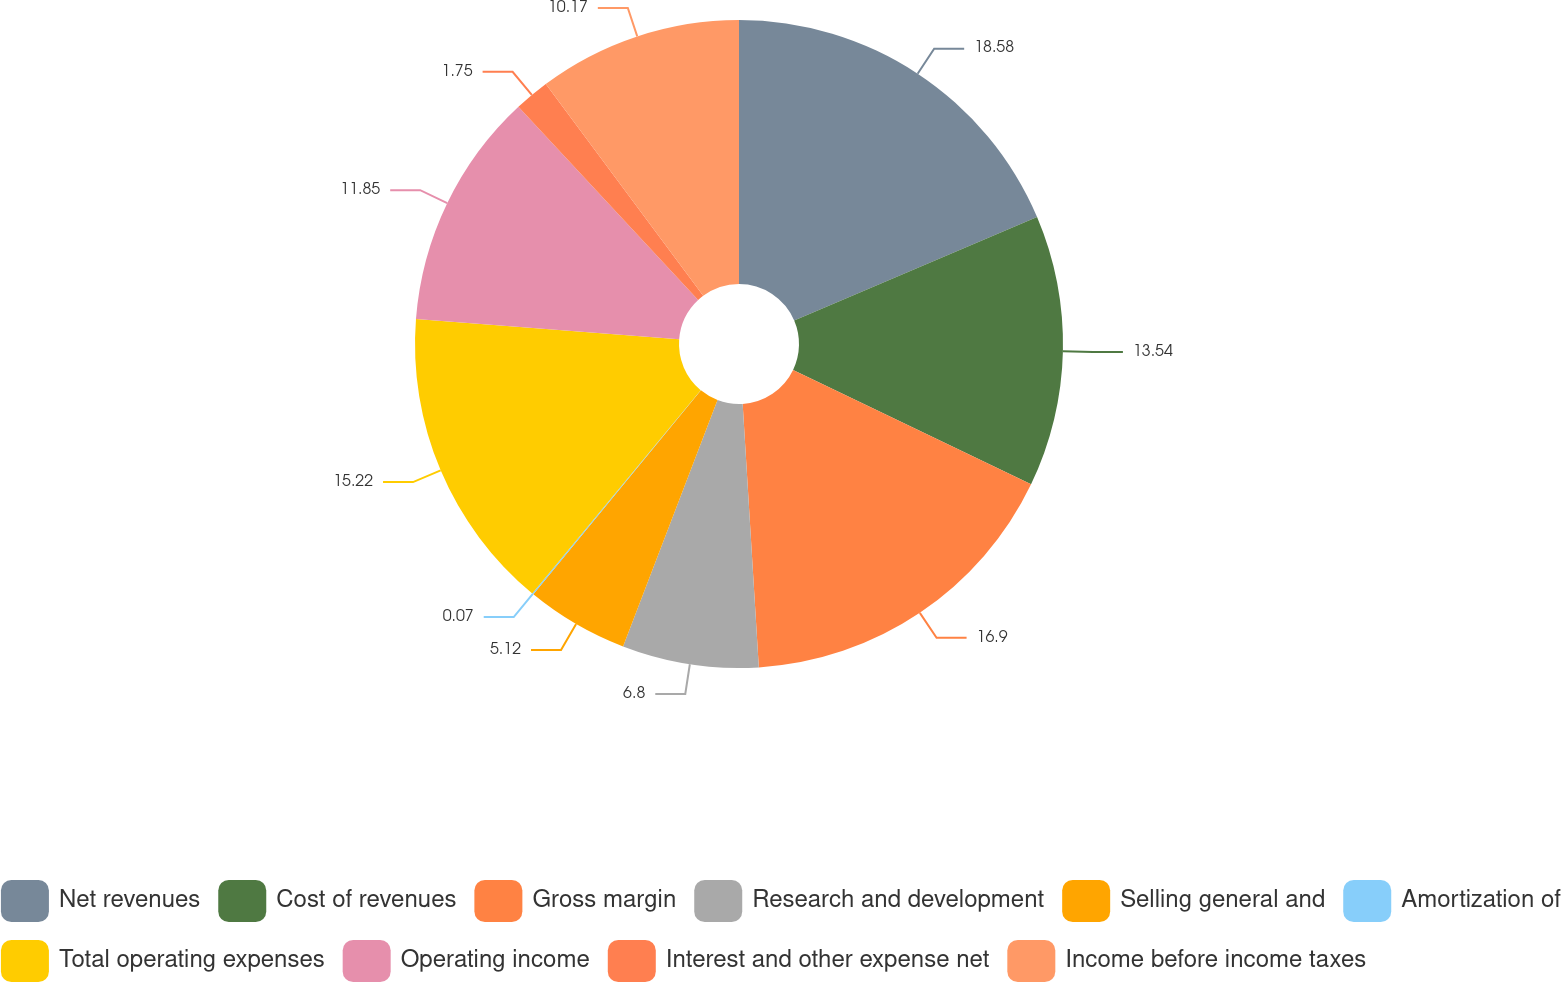Convert chart. <chart><loc_0><loc_0><loc_500><loc_500><pie_chart><fcel>Net revenues<fcel>Cost of revenues<fcel>Gross margin<fcel>Research and development<fcel>Selling general and<fcel>Amortization of<fcel>Total operating expenses<fcel>Operating income<fcel>Interest and other expense net<fcel>Income before income taxes<nl><fcel>18.59%<fcel>13.54%<fcel>16.9%<fcel>6.8%<fcel>5.12%<fcel>0.07%<fcel>15.22%<fcel>11.85%<fcel>1.75%<fcel>10.17%<nl></chart> 